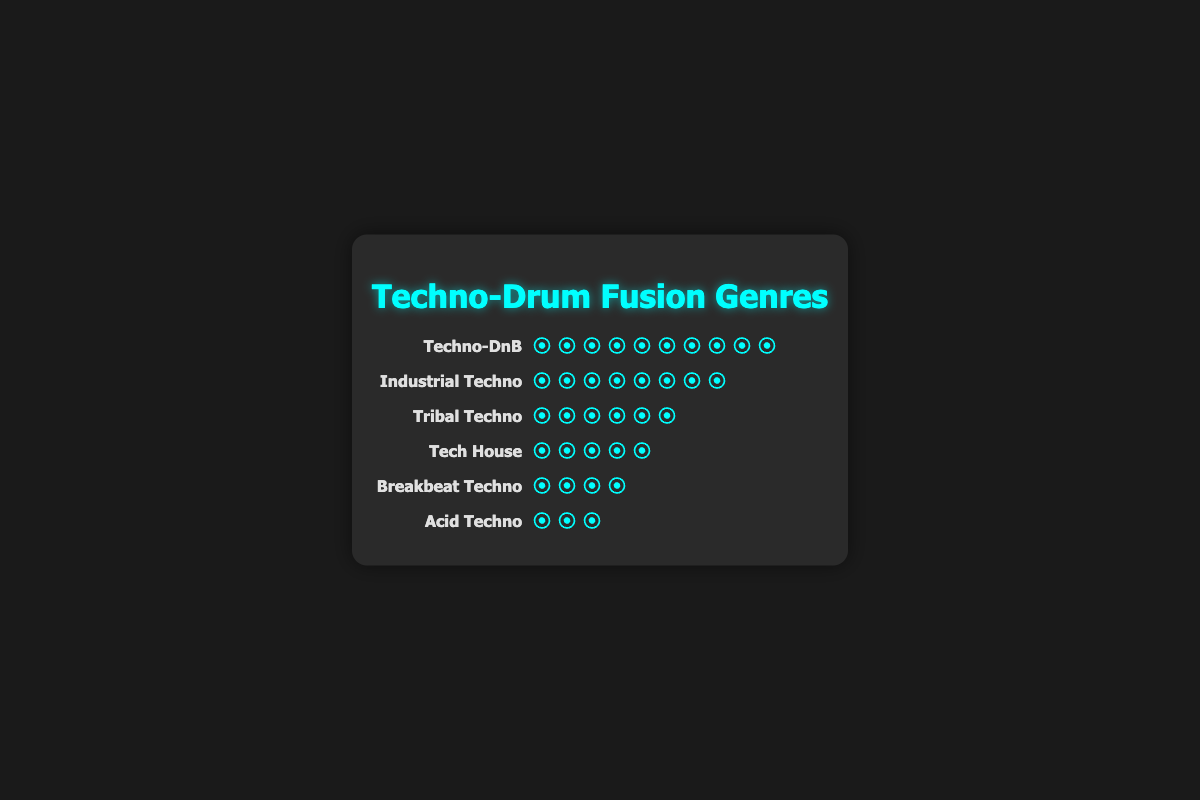What is the most popular genre in the techno-drum fusion tracks? The most popular genre is represented by the genre with the highest count of icons. Techno-DnB has the highest count with 50 icons.
Answer: Techno-DnB How many genres have more than 30 tracks? To find this, we count the numbers of genres with a count greater than 30. This includes Techno-DnB (50) and Industrial Techno (40).
Answer: 2 Which genre has the least number of tracks? The genre with the least number of icons represents the least number of tracks. Acid Techno has the least count with 15 icons.
Answer: Acid Techno What is the total number of tracks across all genres? Sum the counts of tracks for each genre: 50 (Techno-DnB) + 40 (Industrial Techno) + 30 (Tribal Techno) + 25 (Tech House) + 20 (Breakbeat Techno) + 15 (Acid Techno) = 180.
Answer: 180 Which genre has five more tracks than Tech House? To find this, add 5 to the count of Tech House tracks (25). This results in 30, which corresponds to Tribal Techno.
Answer: Tribal Techno Compare Tech House and Breakbeat Techno. Which one has more tracks, and by how much? Tech House has 25 tracks, and Breakbeat Techno has 20 tracks. The difference is 25 - 20 = 5 tracks.
Answer: Tech House by 5 tracks What is the average number of tracks across all genres? The total number of tracks is 180, and there are 6 genres. The average is calculated by dividing the total by the number of genres: 180 / 6 = 30.
Answer: 30 How many genres have fewer tracks than Industrial Techno? Count the genres with icons fewer than Industrial Techno's count (40). These are Tribal Techno (30), Tech House (25), Breakbeat Techno (20), and Acid Techno (15).
Answer: 4 If 10 additional tracks are added to Acid Techno, how many genres will then have the same number of tracks as it? Adding 10 tracks to Acid Techno changes its count to 15 + 10 = 25, matching the count of Tech House. Only Tech House has 25 tracks, so only one genre will match.
Answer: 1 Which genres combined exceed the track count of Techno-DnB? Find combinations of genres that together sum to more than 50 tracks. For example, Industrial Techno (40) and Tribal Techno (30) together sum to 70 tracks.
Answer: Industrial Techno and Tribal Techno 